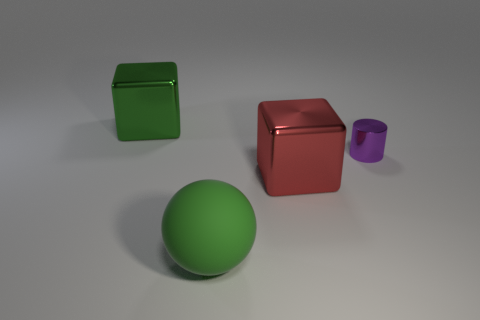How are the objects arranged in relation to each other? The objects are spaced apart on a flat surface. From left to right, we see a green cube, followed by a larger red cube, a green sphere in the foreground, and a smaller purple cylinder to the right. 